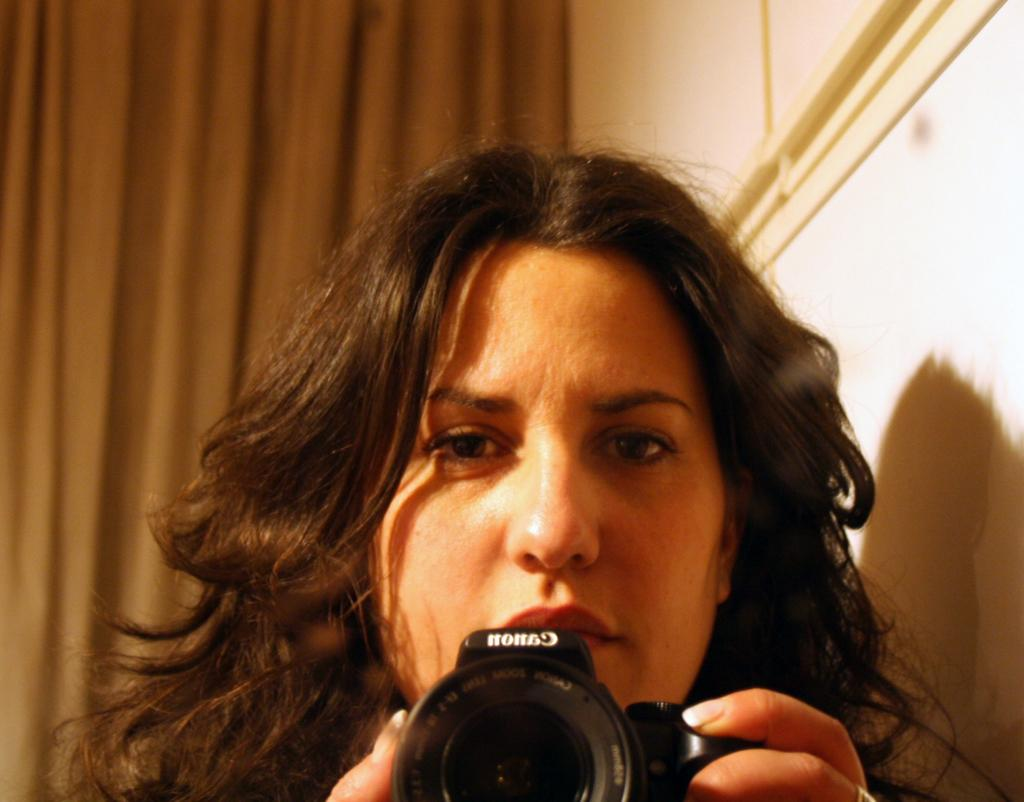What is the main subject of the picture? The main subject of the picture is a lady. What is the lady holding in her hand? A: The lady is holding a camera in her hand. What type of secretary is working in the background of the image? There is no secretary present in the image; it only features a lady holding a camera. 